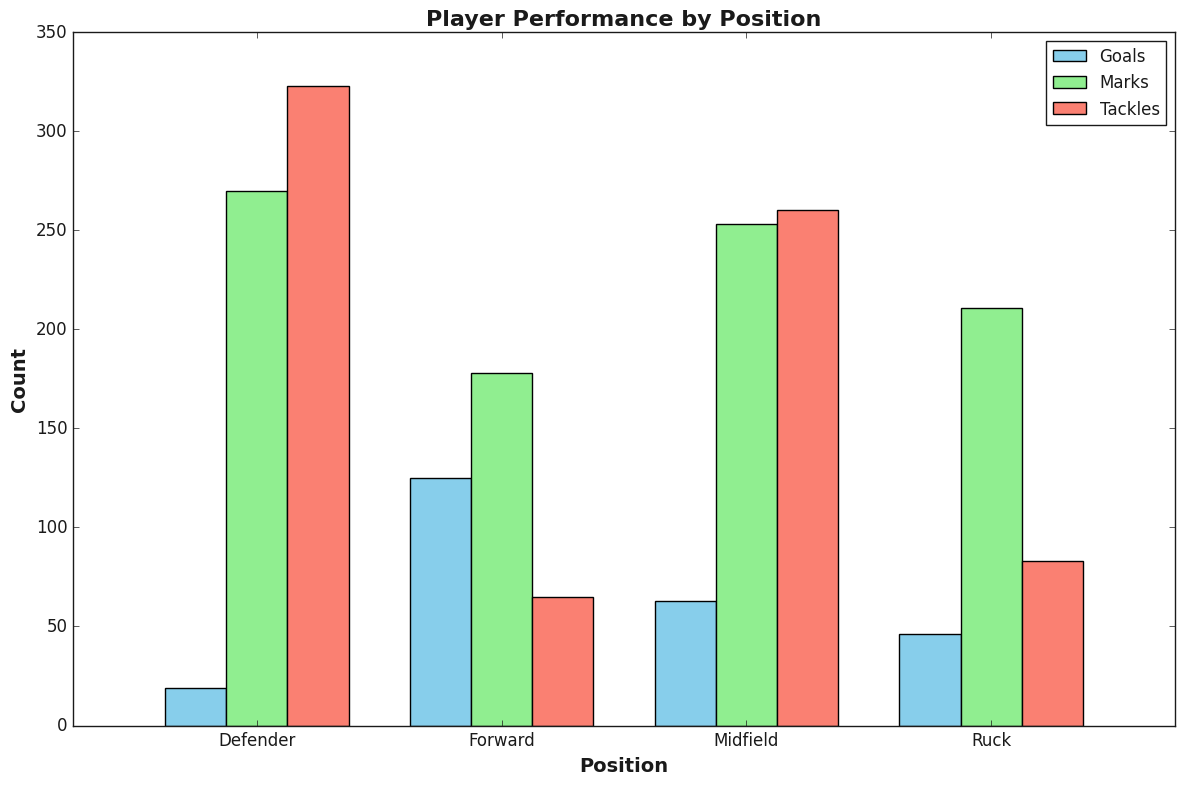What position has the highest total number of goals? Sum the goals for each position and compare: Forward (42+38+45 = 125), Midfield (18+25+20 = 63), Defender (6+8+5 = 19), Ruck (15+17+14 = 46). Forward has the highest total.
Answer: Forward Which position has the most tackles? Sum the tackles for each position and compare: Forward (22+20+23 = 65), Midfield (95+80+85 = 260), Defender (110+105+108 = 323), Ruck (25+30+28 = 83). Defender has the most tackles.
Answer: Defender What is the combined total of marks and tackles for the Ruck position? Sum marks and tackles for Ruck: Marks (70+68+73 = 211) and Tackles (25+30+28 = 83), combined total is 211 + 83 = 294.
Answer: 294 Which position scores more goals, Forwards or Midfields, and by how much? Sum goals for both positions and compare: Forward (42+38+45 = 125), Midfield (18+25+20 = 63). The difference is 125 - 63 = 62.
Answer: Forward by 62 Which set of bars, Goals, Marks, or Tackles, for Defenders is the tallest? Observe the bars representing Defenders: Goals (smallest), Marks (medium), Tackles (tallest).
Answer: Tackles What position has the lowest total number of marks? Sum the marks for each position and compare: Forward (60+63+55 = 178), Midfield (85+78+90 = 253), Defender (90+92+88 = 270), Ruck (70+68+73 = 211). Forward has the lowest total.
Answer: Forward Between the Forward and Ruck positions, which has the higher number of tackles, and what is the difference? Sum tackles for both positions: Forward (22+20+23 = 65), Ruck (25+30+28 = 83). The difference is 83 - 65 = 18.
Answer: Ruck by 18 What is the average number of marks for Midfielders? Sum marks for Midfielders and divide by the number of data points: (85+78+90) / 3 = 253 / 3 ≈ 84.33.
Answer: ~84.33 Considering the total counts of Marks for all positions, which position has the median total? Arrange total Marks: Forward (178), Ruck (211), Midfield (253), Defender (270). The median is Midfield.
Answer: Midfield 